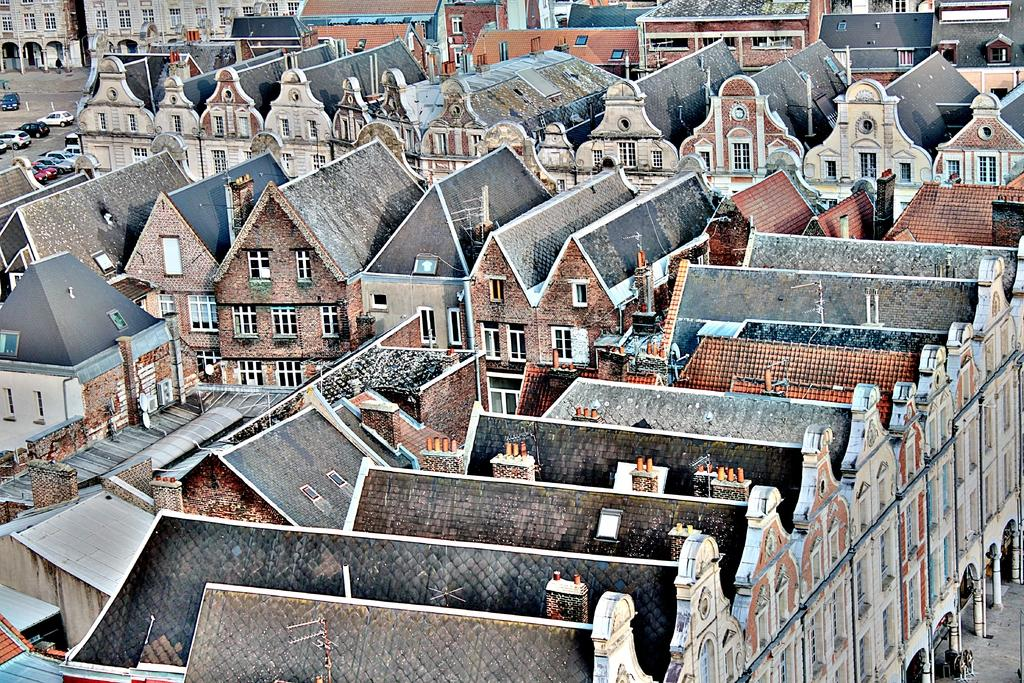What type of structures are visible in the image? There are house buildings in the image. What can be seen in the background of the image? There is a path in the background of the image. Are there any vehicles visible in the image? Yes, there are cars parked near the building in the background. Where can the store be found in the image? There is no store present in the image. What type of notebook is being used by the person in the image? There is no person or notebook visible in the image. 